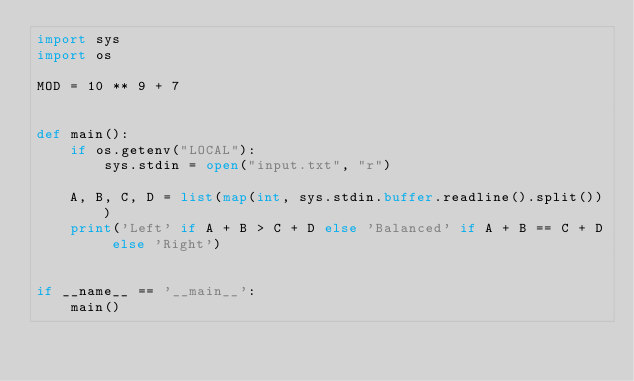<code> <loc_0><loc_0><loc_500><loc_500><_Python_>import sys
import os

MOD = 10 ** 9 + 7


def main():
    if os.getenv("LOCAL"):
        sys.stdin = open("input.txt", "r")

    A, B, C, D = list(map(int, sys.stdin.buffer.readline().split()))
    print('Left' if A + B > C + D else 'Balanced' if A + B == C + D else 'Right')


if __name__ == '__main__':
    main()
</code> 